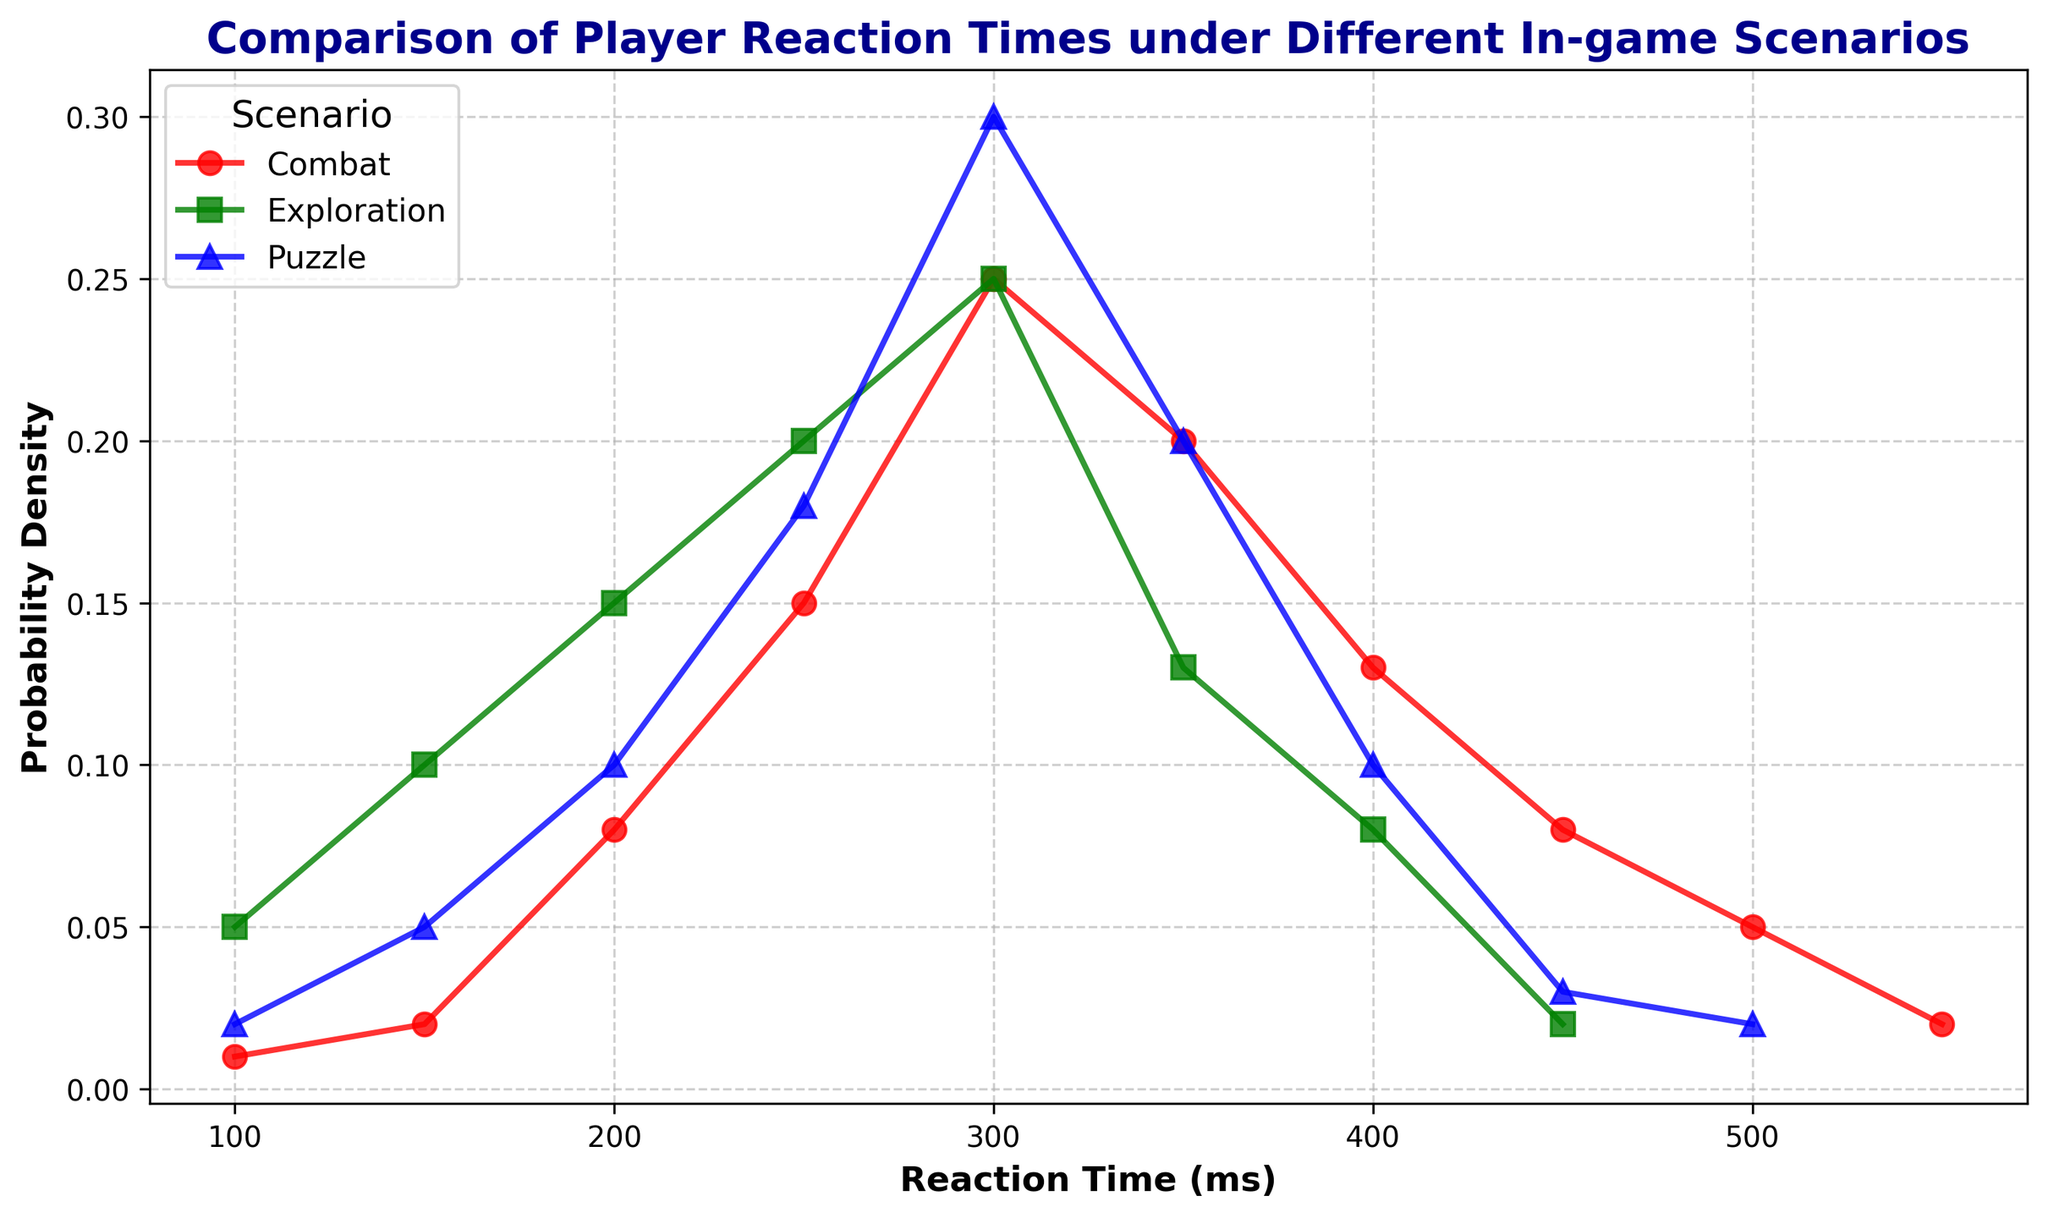What is the reaction time where the combat scenario has the highest probability density? We look at the combat scenario and identify the peak of the probability density function. The highest probability density for combat occurs at a reaction time of 300 ms with a probability density of 0.25.
Answer: 300 ms How do the peak reaction times compare between the combat and exploration scenarios? For the combat scenario, the peak reaction time is 300 ms with a probability density of 0.25. Similarly, for the exploration scenario, the peak reaction time is also 300 ms with the same probability density of 0.25.
Answer: They are the same, 300 ms Which scenario shows a wider spread in reaction times? By visually comparing the width of the curves at the base, we can see the exploration scenario spreads more uniformly over a broader range of reaction times, from 100 ms to 450 ms. In contrast, combat and puzzle scenarios have narrower spreads.
Answer: Exploration At which reaction time is there a noticeable drop in the probability density for the puzzle scenario? Looking at the puzzle scenario curve, there is a noticeable drop in probability density after 350 ms. The probability density decreases from 0.20 to 0.10 between 350 ms and 400 ms.
Answer: 350 ms What is the probability density for a reaction time of 200 ms in each scenario? For 200 ms, the probability density values for the scenarios are given by the plot: for combat, it is 0.08; for exploration, it is 0.15; and for puzzles, it is 0.10.
Answer: Combat: 0.08, Exploration: 0.15, Puzzle: 0.10 Which scenario has the highest probability density at a reaction time of 450 ms? At 450 ms, the highest probability density among the scenarios can be identified by comparing the points on the plot. Combat has a probability density of 0.08, exploration has 0.02, and puzzles have 0.03. Thus, the combat scenario has the highest probability density at 450 ms.
Answer: Combat How does the probability density change for the combat scenario between 250 ms and 400 ms? For the combat scenario, the probability density increases from 0.15 at 250 ms to a peak of 0.25 at 300 ms, then decreases to 0.20 at 350 ms, and further down to 0.13 at 400 ms. This indicates an initial rise to a peak, followed by a decline.
Answer: It increases to 0.25 and then decreases to 0.13 What reaction time has the lowest probability density for exploration? We look at the exploration curve to find the lowest point. The lowest probability density is at a reaction time of 450 ms with a probability density of 0.02.
Answer: 450 ms 